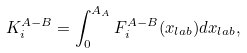<formula> <loc_0><loc_0><loc_500><loc_500>K ^ { A - B } _ { i } = \int ^ { A _ { A } } _ { 0 } F ^ { A - B } _ { i } ( x _ { l a b } ) d x _ { l a b } ,</formula> 